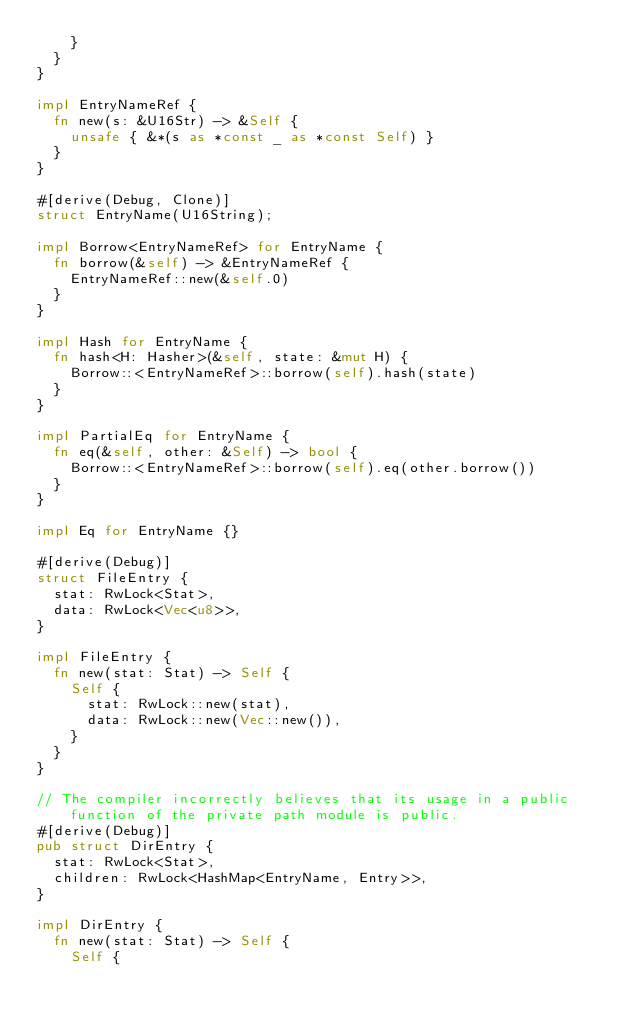<code> <loc_0><loc_0><loc_500><loc_500><_Rust_>		}
	}
}

impl EntryNameRef {
	fn new(s: &U16Str) -> &Self {
		unsafe { &*(s as *const _ as *const Self) }
	}
}

#[derive(Debug, Clone)]
struct EntryName(U16String);

impl Borrow<EntryNameRef> for EntryName {
	fn borrow(&self) -> &EntryNameRef {
		EntryNameRef::new(&self.0)
	}
}

impl Hash for EntryName {
	fn hash<H: Hasher>(&self, state: &mut H) {
		Borrow::<EntryNameRef>::borrow(self).hash(state)
	}
}

impl PartialEq for EntryName {
	fn eq(&self, other: &Self) -> bool {
		Borrow::<EntryNameRef>::borrow(self).eq(other.borrow())
	}
}

impl Eq for EntryName {}

#[derive(Debug)]
struct FileEntry {
	stat: RwLock<Stat>,
	data: RwLock<Vec<u8>>,
}

impl FileEntry {
	fn new(stat: Stat) -> Self {
		Self {
			stat: RwLock::new(stat),
			data: RwLock::new(Vec::new()),
		}
	}
}

// The compiler incorrectly believes that its usage in a public function of the private path module is public.
#[derive(Debug)]
pub struct DirEntry {
	stat: RwLock<Stat>,
	children: RwLock<HashMap<EntryName, Entry>>,
}

impl DirEntry {
	fn new(stat: Stat) -> Self {
		Self {</code> 